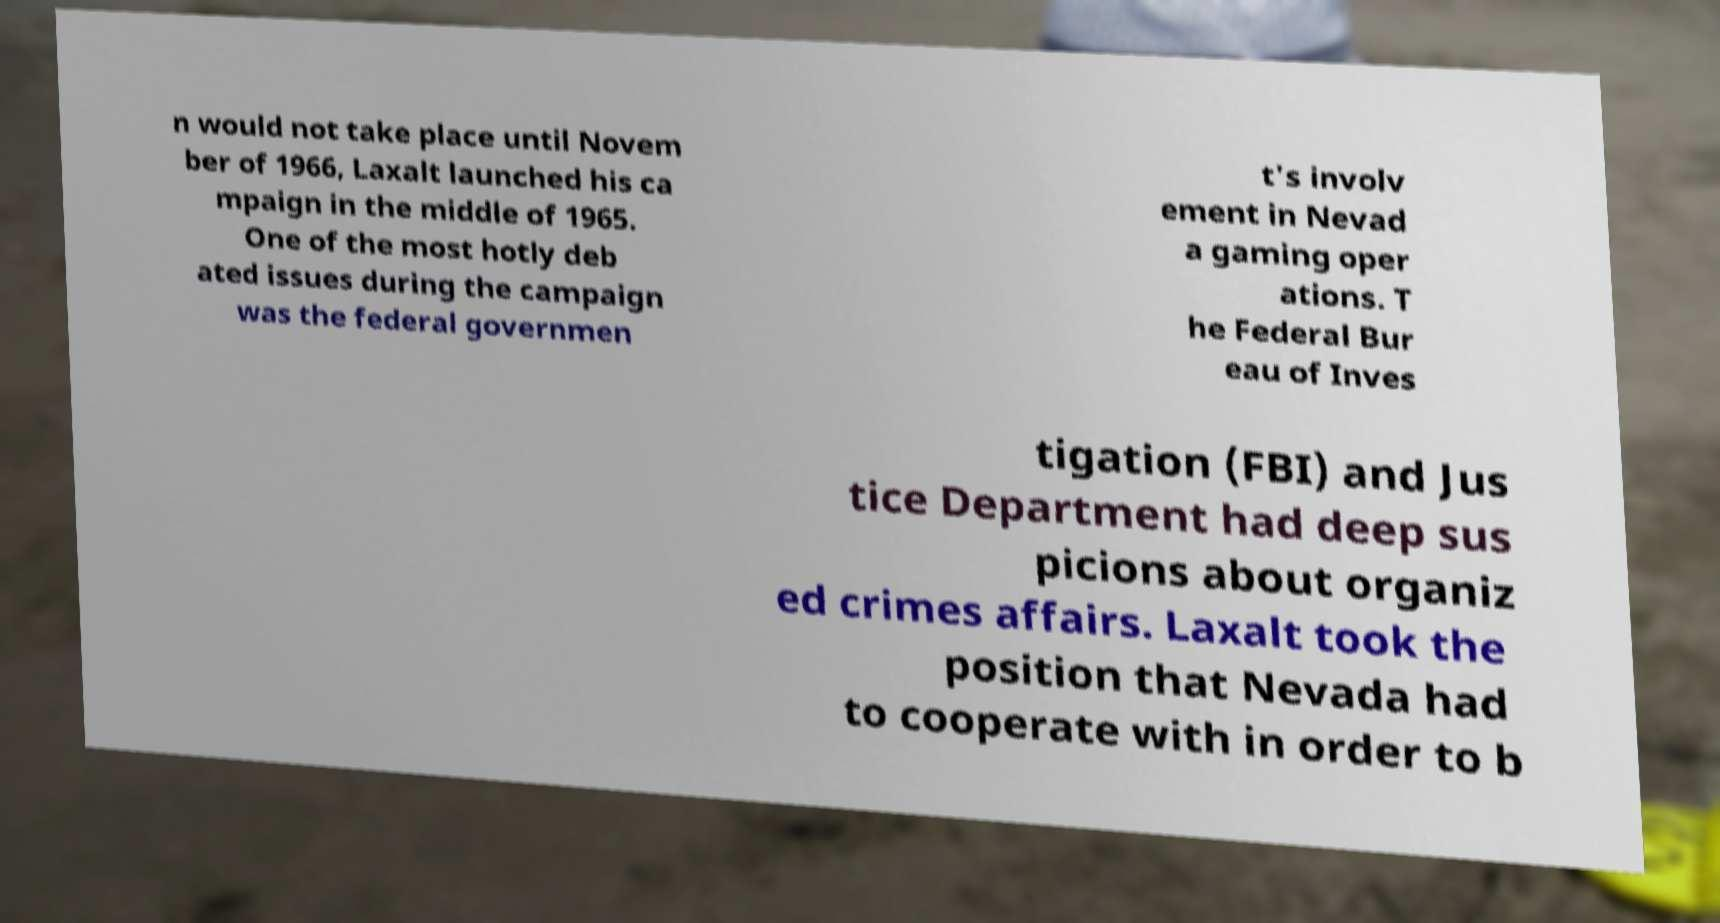For documentation purposes, I need the text within this image transcribed. Could you provide that? n would not take place until Novem ber of 1966, Laxalt launched his ca mpaign in the middle of 1965. One of the most hotly deb ated issues during the campaign was the federal governmen t's involv ement in Nevad a gaming oper ations. T he Federal Bur eau of Inves tigation (FBI) and Jus tice Department had deep sus picions about organiz ed crimes affairs. Laxalt took the position that Nevada had to cooperate with in order to b 